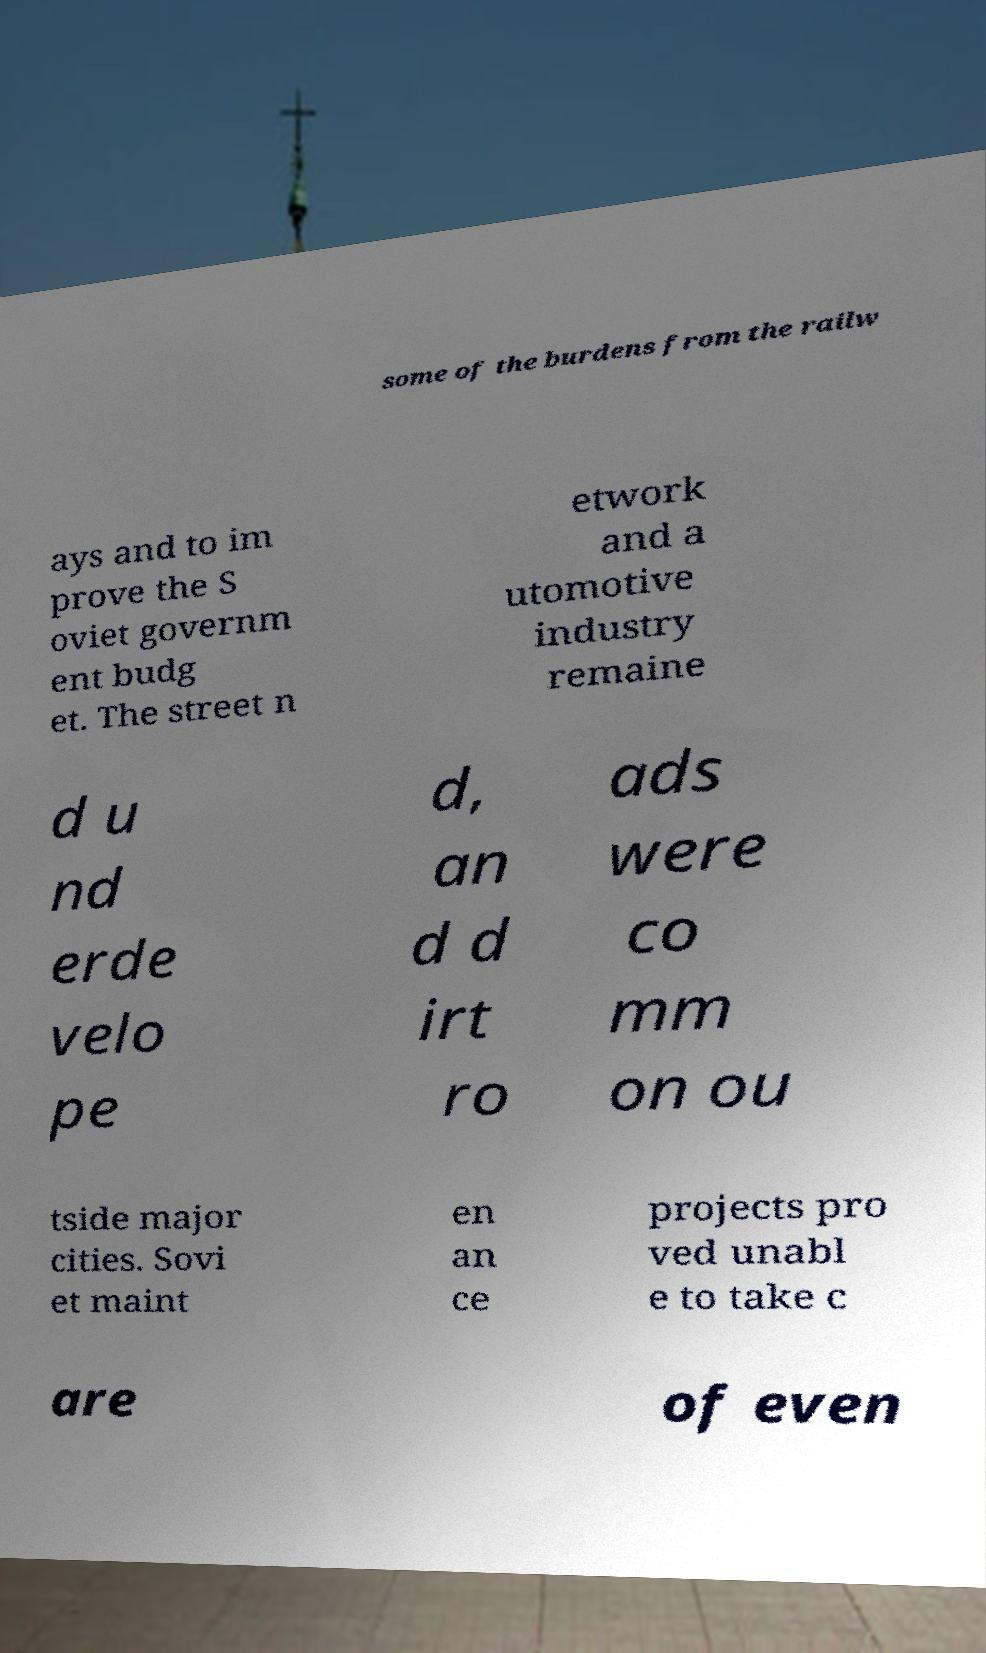For documentation purposes, I need the text within this image transcribed. Could you provide that? some of the burdens from the railw ays and to im prove the S oviet governm ent budg et. The street n etwork and a utomotive industry remaine d u nd erde velo pe d, an d d irt ro ads were co mm on ou tside major cities. Sovi et maint en an ce projects pro ved unabl e to take c are of even 